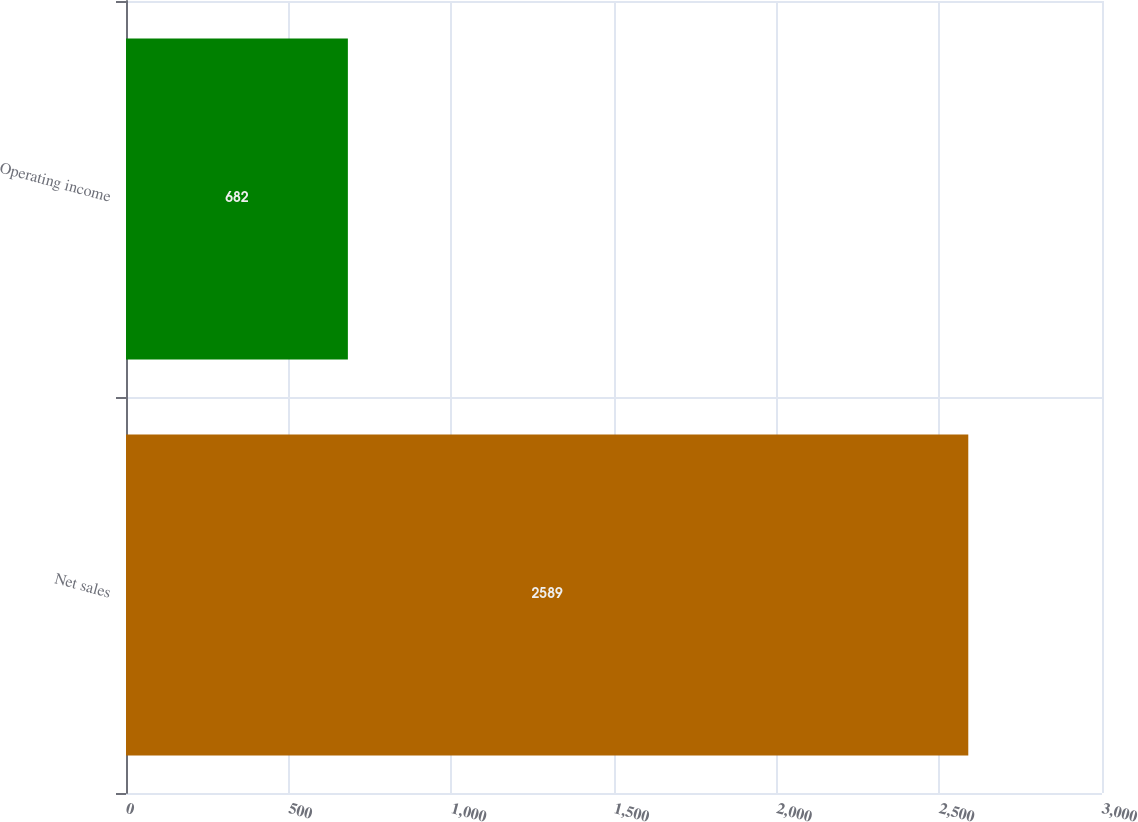Convert chart to OTSL. <chart><loc_0><loc_0><loc_500><loc_500><bar_chart><fcel>Net sales<fcel>Operating income<nl><fcel>2589<fcel>682<nl></chart> 